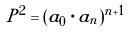Convert formula to latex. <formula><loc_0><loc_0><loc_500><loc_500>P ^ { 2 } = ( a _ { 0 } \cdot a _ { n } ) ^ { n + 1 }</formula> 